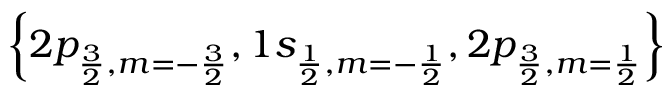<formula> <loc_0><loc_0><loc_500><loc_500>\left \{ 2 p _ { \frac { 3 } { 2 } , m = - \frac { 3 } { 2 } } , 1 s _ { \frac { 1 } { 2 } , m = - \frac { 1 } { 2 } } , 2 p _ { \frac { 3 } { 2 } , m = \frac { 1 } { 2 } } \right \}</formula> 